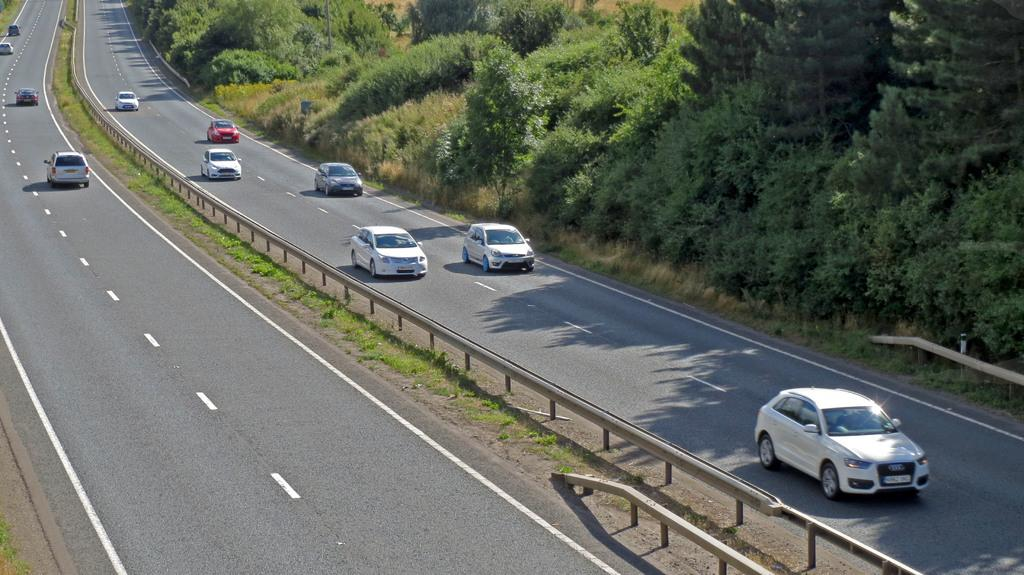What can be seen in the image? There are vehicles in the image. What are the vehicles doing? The vehicles are moving on a road. What can be seen in the distance in the image? There are trees in the background of the image. How many cacti can be seen in the aftermath of the accident in the image? There is no mention of an accident or cacti in the image. The image shows vehicles moving on a road with trees in the background. 